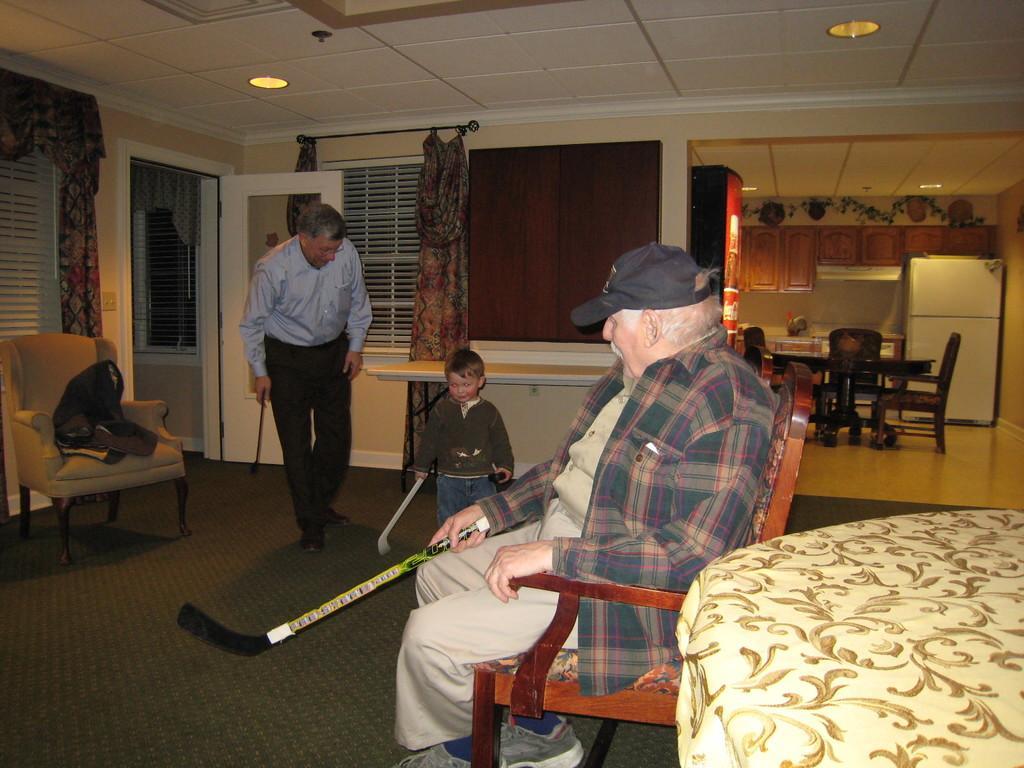Could you give a brief overview of what you see in this image? The person in the right is sitting in chair and holding a hockey stick and there are two other persons standing beside him who are holding two hockey sticks in there hands. 